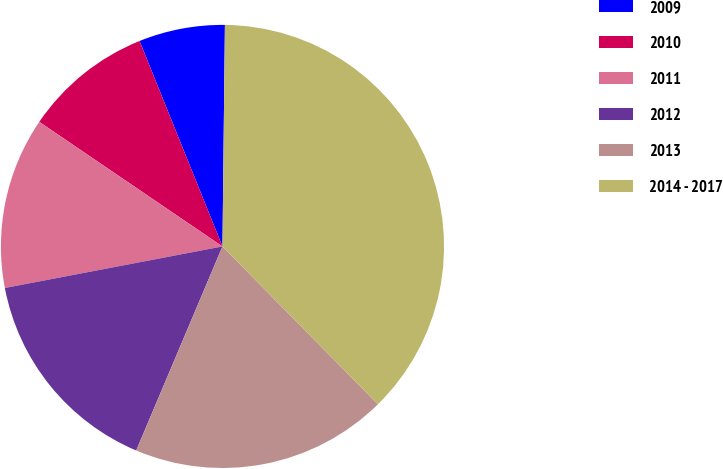Convert chart to OTSL. <chart><loc_0><loc_0><loc_500><loc_500><pie_chart><fcel>2009<fcel>2010<fcel>2011<fcel>2012<fcel>2013<fcel>2014 - 2017<nl><fcel>6.28%<fcel>9.39%<fcel>12.51%<fcel>15.63%<fcel>18.74%<fcel>37.45%<nl></chart> 